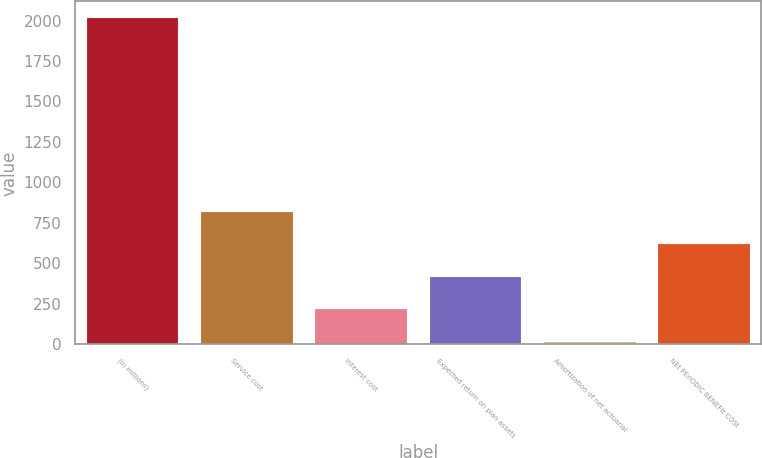Convert chart. <chart><loc_0><loc_0><loc_500><loc_500><bar_chart><fcel>(in millions)<fcel>Service cost<fcel>Interest cost<fcel>Expected return on plan assets<fcel>Amortization of net actuarial<fcel>NEt PErIODIC BENEFIt COSt<nl><fcel>2018<fcel>818<fcel>218<fcel>418<fcel>18<fcel>618<nl></chart> 